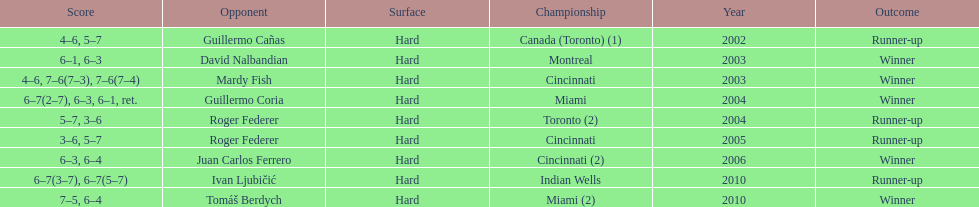On how many occasions were roddick's competitors not from the usa? 8. 